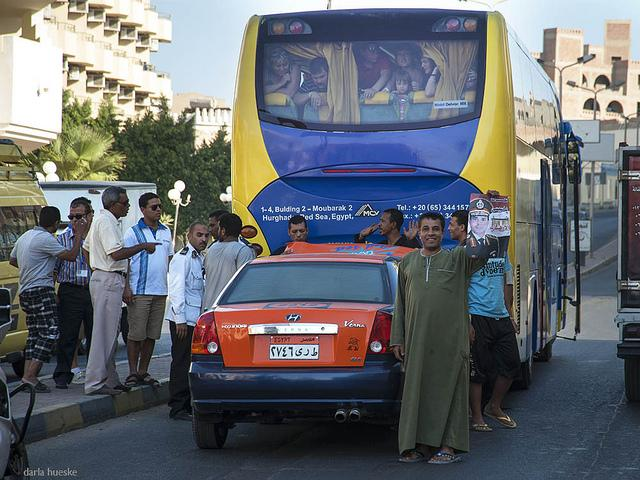What do those gathered look at here? Please explain your reasoning. car crash. The car crashed into the bus. 